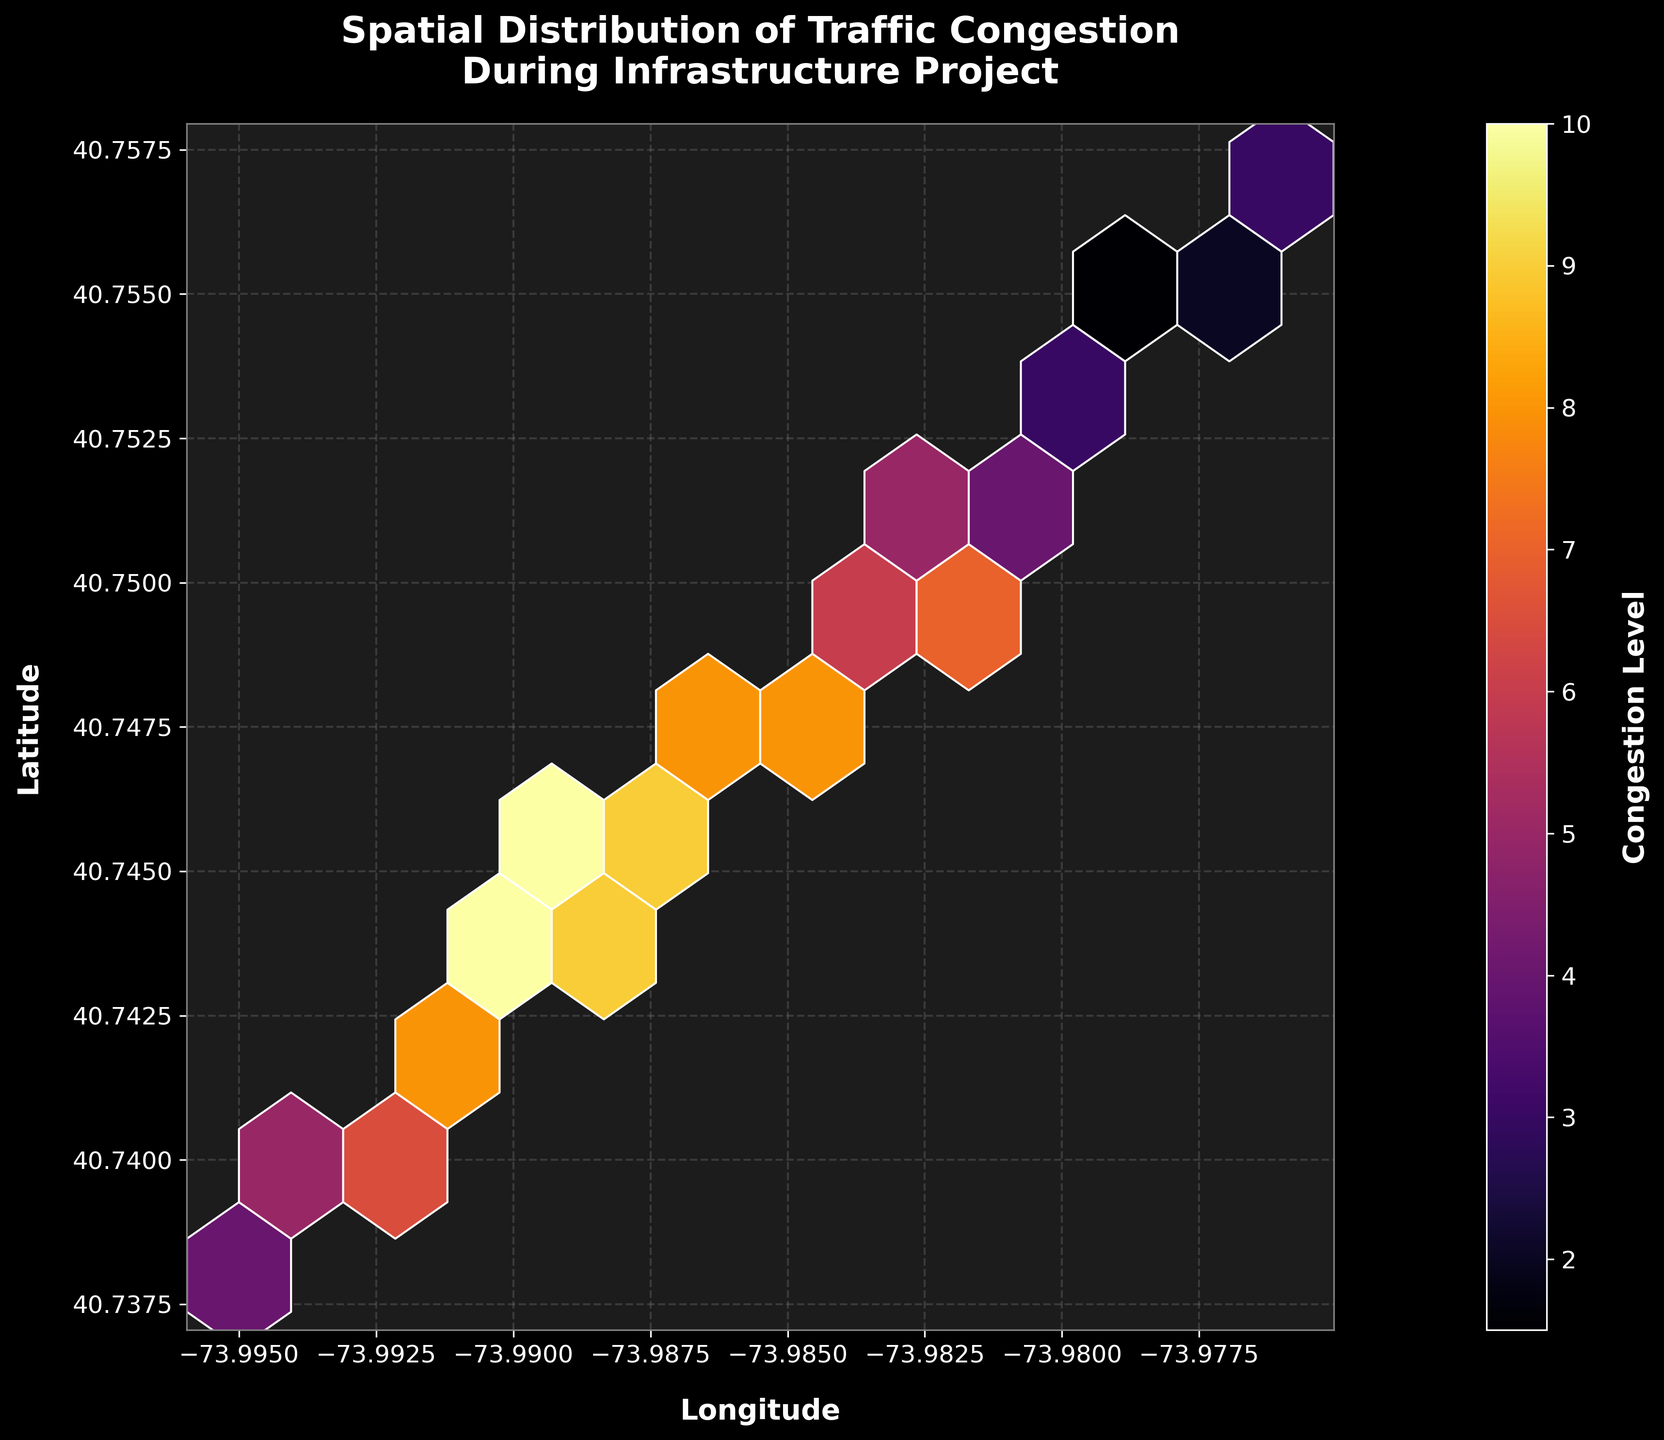What is the title of the figure? The title is found at the top of the figure and provides a succinct description of the plot's content: "Spatial Distribution of Traffic Congestion During Infrastructure Project".
Answer: Spatial Distribution of Traffic Congestion During Infrastructure Project What are the labels for the x and y axes? Axis labels provide context about the plotted variables. The x-axis is labeled "Longitude" and the y-axis is labeled "Latitude".
Answer: Longitude and Latitude What color scheme is used in the hexbin plot? Observing the plot, the hexagonal bins use a color scheme transitioning from dark to bright, specifically the 'inferno' colormap, which ranges from dark purple to bright yellow.
Answer: Inferno Which area experiences the highest congestion level? The bins with the brightest color indicate the highest congestion levels. In this case, areas around coordinates (-73.989, 40.745) to (-73.990, 40.743) appear to have the highest congestion level.
Answer: Around (-73.989, 40.745) to (-73.990, 40.743) How many bins are in the plot? Counting the hexagonal bins visually, there are 10 columns and 10 rows, resulting in a total of 10x10 = 100 bins in the plot.
Answer: 100 bins What is the grid size of the hexbin plot? The grid size defines the number of hexagonal bins along each axis. With visible bins forming a 10x10 grid, the grid size is 10.
Answer: 10 Are there areas with very low congestion levels? If yes, where? The darkest bins indicate the lowest congestion levels. The coordinates around (-73.978, 40.755) and (-73.976, 40.757) have very low congestion levels.
Answer: Around (-73.978, 40.755) and (-73.976, 40.757) How does the density of bins relate to congestion levels? In a hexbin plot, denser clusters of bins often indicate higher data point concentrations. Here, the brightest clusters of bins suggest higher congestion levels compared to sparser, darker bins.
Answer: Denser clusters indicate higher congestion How does the congestion level vary from south to north across the plotted area? Observing the vertical distribution of bin colors, congestion tends to be higher (brighter color) in the central and southern parts of the plot (lower latitude) compared to the northern parts (higher latitude).
Answer: Higher in central and southern, lower in northern Which coordinate quadrant has lower congestion? Dividing the plot into quadrants by the middle coordinates, the northeastern quadrant (higher longitudes and latitudes) has generally darker bins, indicating lower congestion levels.
Answer: Northeastern quadrant 